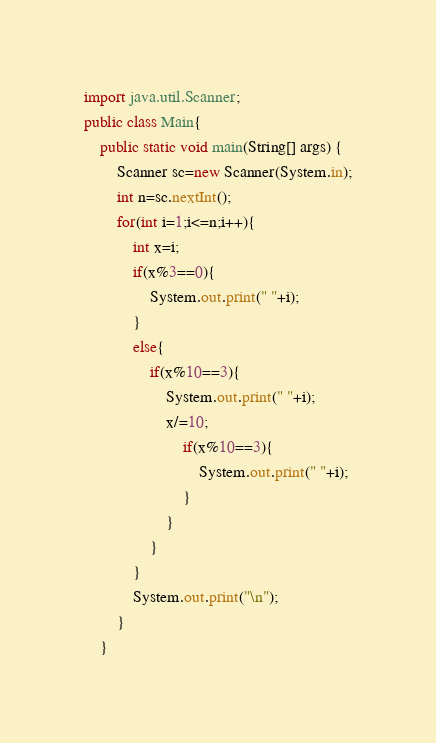Convert code to text. <code><loc_0><loc_0><loc_500><loc_500><_Java_>import java.util.Scanner;
public class Main{
    public static void main(String[] args) {
        Scanner sc=new Scanner(System.in);
        int n=sc.nextInt();
        for(int i=1;i<=n;i++){
            int x=i;
            if(x%3==0){
                System.out.print(" "+i);
            }
            else{
                if(x%10==3){
                    System.out.print(" "+i);
                    x/=10;
                        if(x%10==3){
                            System.out.print(" "+i);
                        }
                    }
                }
            }
            System.out.print("\n");
        }
    }
</code> 